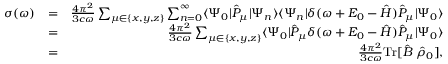<formula> <loc_0><loc_0><loc_500><loc_500>\begin{array} { r l r } { \sigma ( \omega ) } & { = } & { \frac { 4 \pi ^ { 2 } } { 3 c \omega } \sum _ { \mu \in \{ x , y , z \} } \sum _ { n = 0 } ^ { \infty } { \langle \Psi _ { 0 } | } \hat { P } _ { \mu } { | \Psi _ { n } \rangle } { \langle \Psi _ { n } | } \delta ( \omega + E _ { 0 } - \hat { H } ) \hat { P } _ { \mu } { | \Psi _ { 0 } \rangle } } \\ & { = } & { \frac { 4 \pi ^ { 2 } } { 3 c \omega } \sum _ { \mu \in \{ x , y , z \} } { \langle \Psi _ { 0 } | } \hat { P } _ { \mu } \delta ( \omega + E _ { 0 } - \hat { H } ) \hat { P } _ { \mu } { | \Psi _ { 0 } \rangle } } \\ & { = } & { \frac { 4 \pi ^ { 2 } } { 3 c \omega } { T r } [ \hat { B } \, \hat { \rho } _ { 0 } ] , } \end{array}</formula> 